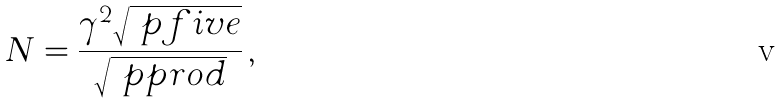Convert formula to latex. <formula><loc_0><loc_0><loc_500><loc_500>N = \frac { \gamma ^ { 2 } \sqrt { \ p f i v e } } { \sqrt { \ p p r o d } } \, ,</formula> 